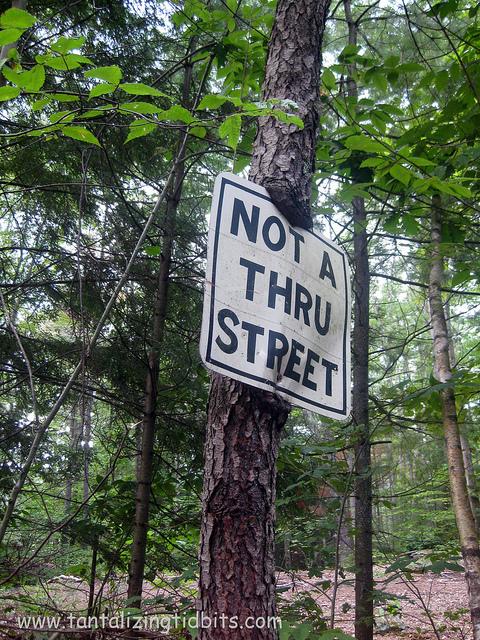Is the post and the sign made of metal?
Short answer required. No. What is the sign attached too?
Be succinct. Tree. What does the sign say?
Keep it brief. Not a thru street. What is in the background?
Answer briefly. Trees. 